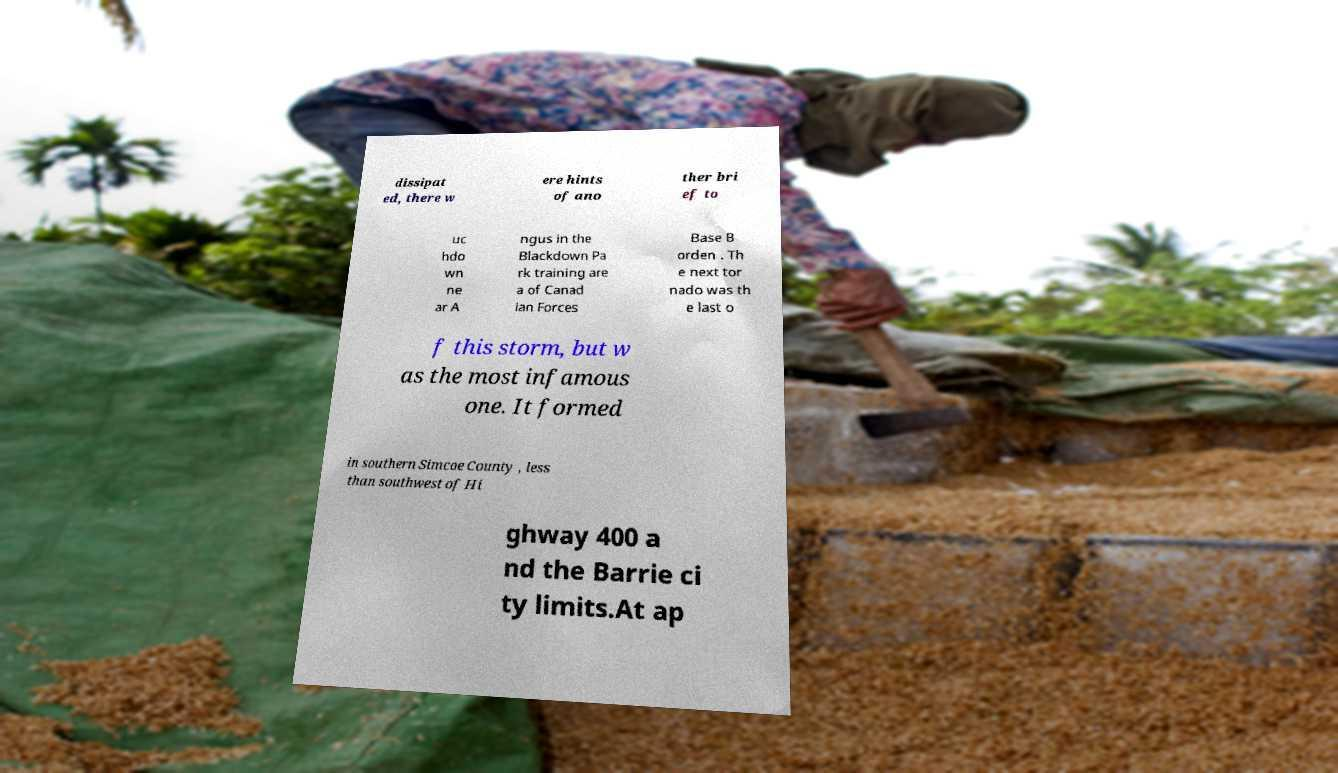What messages or text are displayed in this image? I need them in a readable, typed format. dissipat ed, there w ere hints of ano ther bri ef to uc hdo wn ne ar A ngus in the Blackdown Pa rk training are a of Canad ian Forces Base B orden . Th e next tor nado was th e last o f this storm, but w as the most infamous one. It formed in southern Simcoe County , less than southwest of Hi ghway 400 a nd the Barrie ci ty limits.At ap 